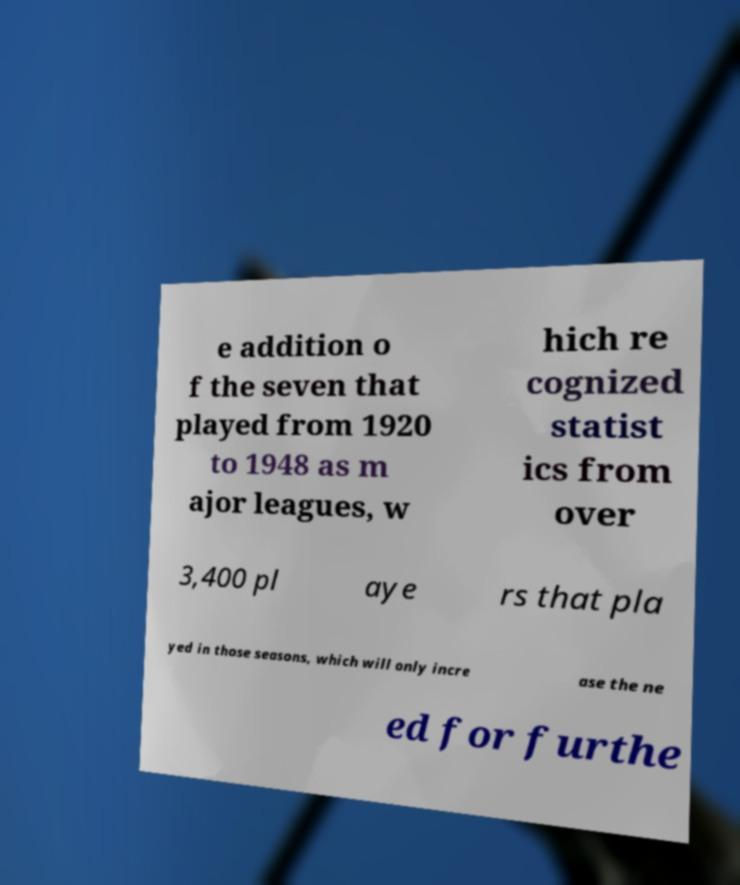Please read and relay the text visible in this image. What does it say? e addition o f the seven that played from 1920 to 1948 as m ajor leagues, w hich re cognized statist ics from over 3,400 pl aye rs that pla yed in those seasons, which will only incre ase the ne ed for furthe 